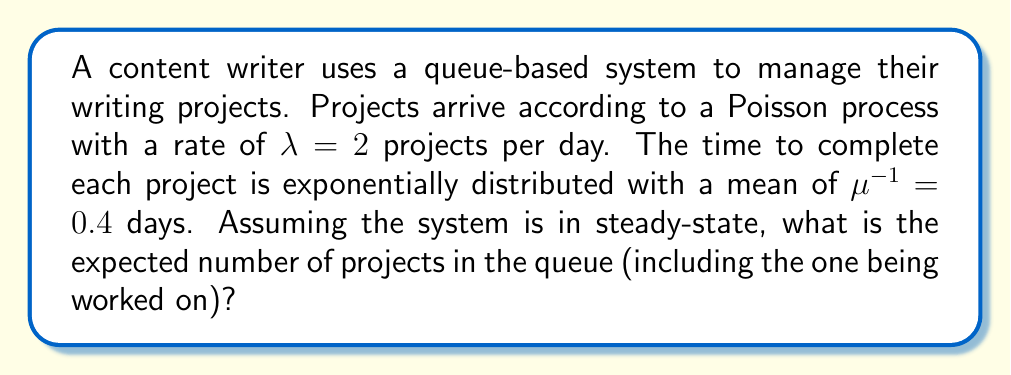Could you help me with this problem? To solve this problem, we can use the M/M/1 queue model, which is appropriate for our scenario where arrivals follow a Poisson process and service times are exponentially distributed.

Step 1: Calculate the utilization factor $\rho$
$$\rho = \frac{\lambda}{\mu} = \frac{2}{1/0.4} = 2 \cdot 0.4 = 0.8$$

Step 2: Check if the system is stable
For a stable system, we need $\rho < 1$. Here, $\rho = 0.8 < 1$, so the system is stable.

Step 3: Calculate the expected number of projects in the system
For an M/M/1 queue, the expected number of customers (projects) in the system, including the one being served, is given by:

$$L = \frac{\rho}{1-\rho} = \frac{0.8}{1-0.8} = \frac{0.8}{0.2} = 4$$

Therefore, the expected number of projects in the queue, including the one being worked on, is 4.
Answer: 4 projects 